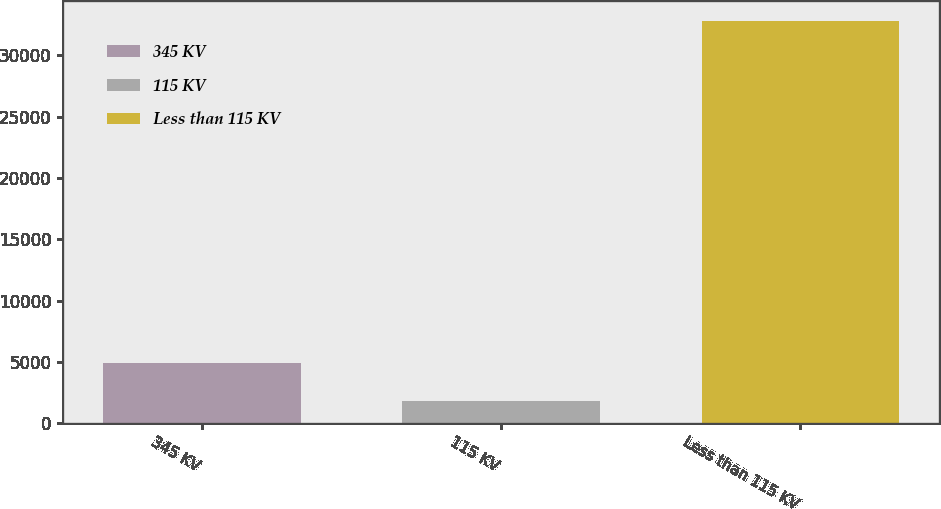Convert chart to OTSL. <chart><loc_0><loc_0><loc_500><loc_500><bar_chart><fcel>345 KV<fcel>115 KV<fcel>Less than 115 KV<nl><fcel>4918.4<fcel>1817<fcel>32831<nl></chart> 